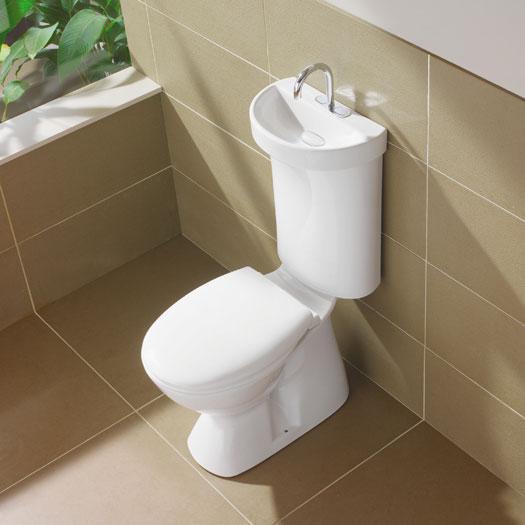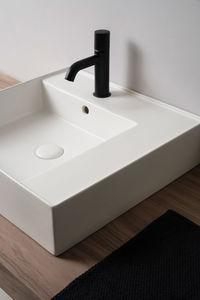The first image is the image on the left, the second image is the image on the right. Analyze the images presented: Is the assertion "The combined images include a white pedestal sink with a narrow, drop-like base, and a gooseneck spout over a rounded bowl-type sink." valid? Answer yes or no. No. The first image is the image on the left, the second image is the image on the right. Evaluate the accuracy of this statement regarding the images: "In one image there is a sink with a very narrow pedestal in the center of the image.". Is it true? Answer yes or no. No. 